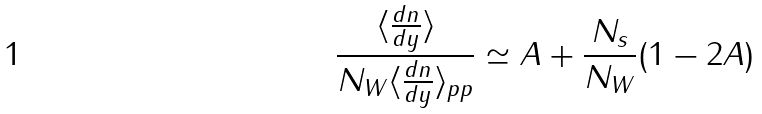<formula> <loc_0><loc_0><loc_500><loc_500>\frac { \langle \frac { d n } { d y } \rangle } { N _ { W } \langle \frac { d n } { d y } \rangle _ { p p } } \simeq A + \frac { N _ { s } } { N _ { W } } ( 1 - 2 A )</formula> 